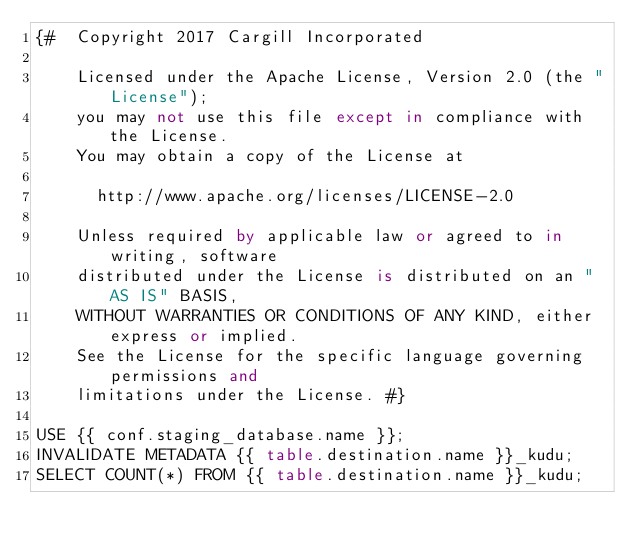Convert code to text. <code><loc_0><loc_0><loc_500><loc_500><_SQL_>{#  Copyright 2017 Cargill Incorporated

    Licensed under the Apache License, Version 2.0 (the "License");
    you may not use this file except in compliance with the License.
    You may obtain a copy of the License at

      http://www.apache.org/licenses/LICENSE-2.0

    Unless required by applicable law or agreed to in writing, software
    distributed under the License is distributed on an "AS IS" BASIS,
    WITHOUT WARRANTIES OR CONDITIONS OF ANY KIND, either express or implied.
    See the License for the specific language governing permissions and
    limitations under the License. #}

USE {{ conf.staging_database.name }};
INVALIDATE METADATA {{ table.destination.name }}_kudu;
SELECT COUNT(*) FROM {{ table.destination.name }}_kudu;</code> 